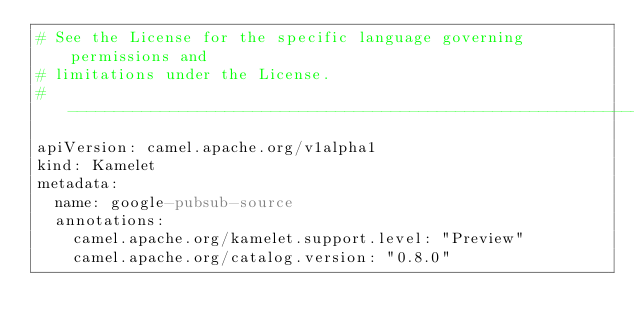Convert code to text. <code><loc_0><loc_0><loc_500><loc_500><_YAML_># See the License for the specific language governing permissions and
# limitations under the License.
# ---------------------------------------------------------------------------
apiVersion: camel.apache.org/v1alpha1
kind: Kamelet
metadata:
  name: google-pubsub-source
  annotations:
    camel.apache.org/kamelet.support.level: "Preview"
    camel.apache.org/catalog.version: "0.8.0"</code> 